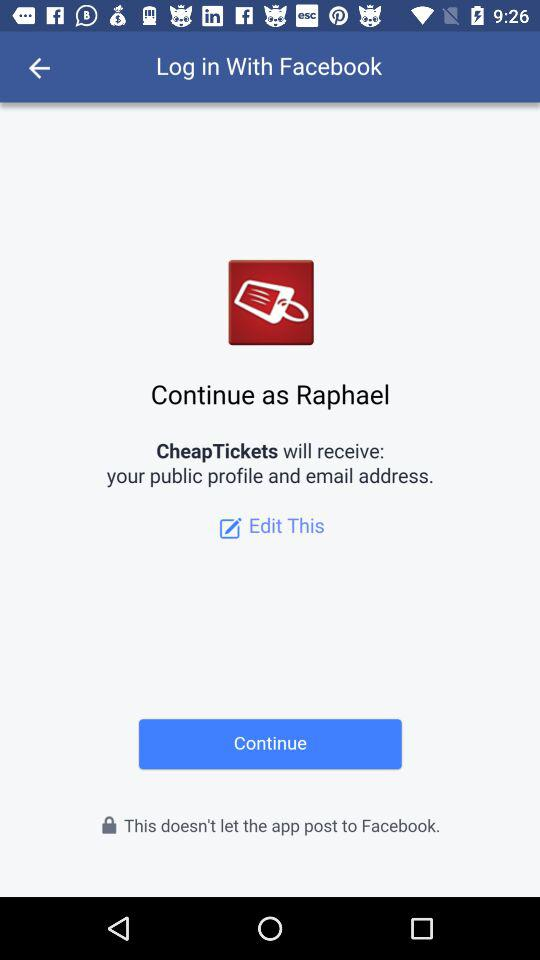What is the user name? The user name is Raphael. 